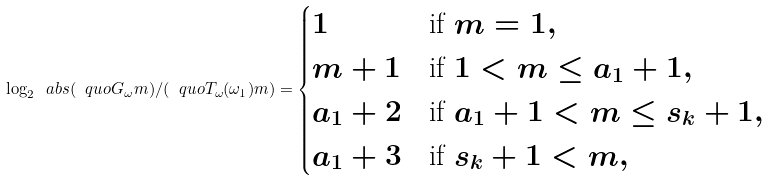Convert formula to latex. <formula><loc_0><loc_0><loc_500><loc_500>\log _ { 2 } \ a b s { ( \ q u o { G _ { \omega } } { m } ) / ( \ q u o { T _ { \omega } ( \omega _ { 1 } ) } { m } ) } = \begin{cases} 1 & \text {if } m = 1 , \\ m + 1 & \text {if } 1 < m \leq a _ { 1 } + 1 , \\ a _ { 1 } + 2 & \text {if } a _ { 1 } + 1 < m \leq s _ { k } + 1 , \\ a _ { 1 } + 3 & \text {if } s _ { k } + 1 < m , \end{cases}</formula> 